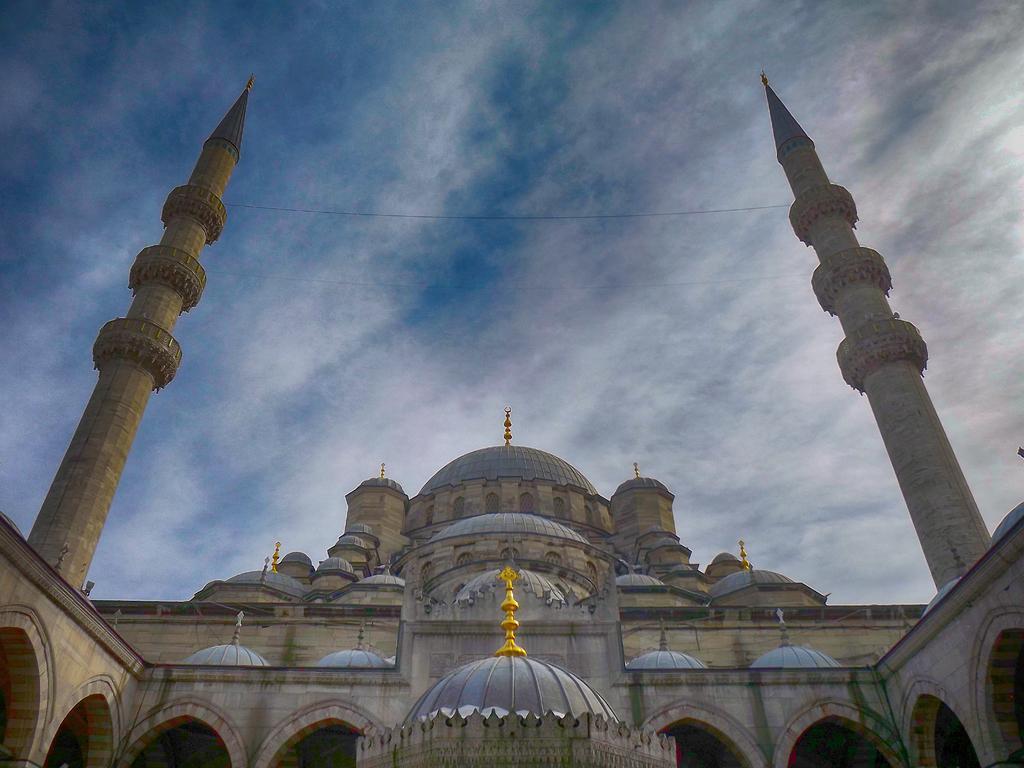In one or two sentences, can you explain what this image depicts? In this image, we can see ancient architecture, walls and pillars. In the background, there is the sky.  